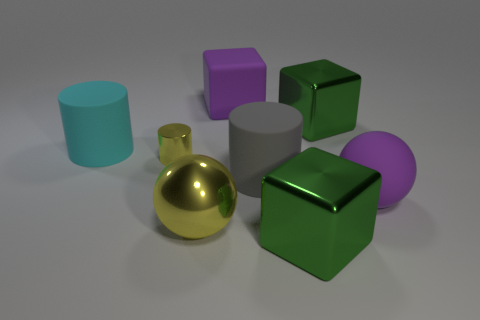Subtract 1 cylinders. How many cylinders are left? 2 Subtract all small yellow metal cylinders. How many cylinders are left? 2 Subtract all purple cylinders. How many green blocks are left? 2 Add 2 green objects. How many objects exist? 10 Subtract all cubes. How many objects are left? 5 Subtract all big green objects. Subtract all big yellow metal balls. How many objects are left? 5 Add 8 shiny cylinders. How many shiny cylinders are left? 9 Add 1 large yellow metal balls. How many large yellow metal balls exist? 2 Subtract 0 red cylinders. How many objects are left? 8 